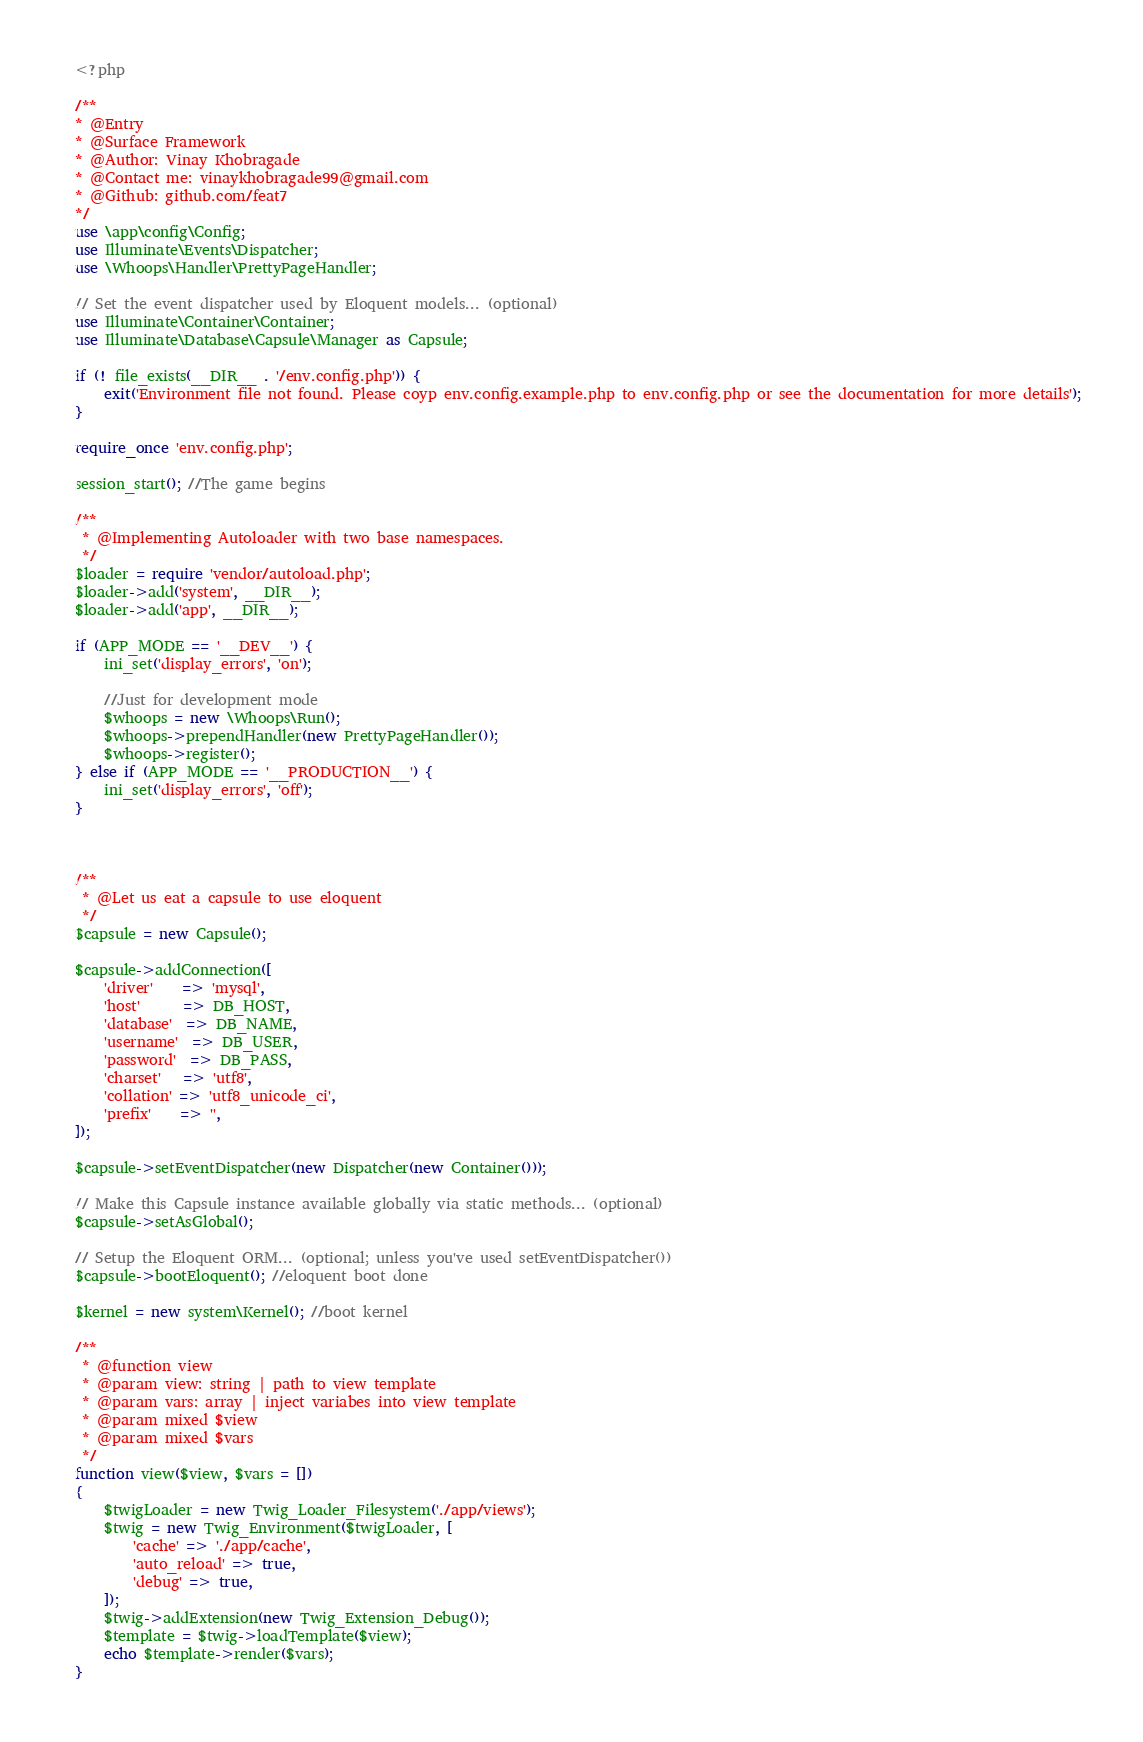Convert code to text. <code><loc_0><loc_0><loc_500><loc_500><_PHP_><?php

/**
* @Entry
* @Surface Framework
* @Author: Vinay Khobragade
* @Contact me: vinaykhobragade99@gmail.com
* @Github: github.com/feat7
*/
use \app\config\Config;
use Illuminate\Events\Dispatcher;
use \Whoops\Handler\PrettyPageHandler;

// Set the event dispatcher used by Eloquent models... (optional)
use Illuminate\Container\Container;
use Illuminate\Database\Capsule\Manager as Capsule;

if (! file_exists(__DIR__ . '/env.config.php')) {
    exit('Environment file not found. Please coyp env.config.example.php to env.config.php or see the documentation for more details');
}

require_once 'env.config.php';

session_start(); //The game begins

/**
 * @Implementing Autoloader with two base namespaces.
 */
$loader = require 'vendor/autoload.php';
$loader->add('system', __DIR__);
$loader->add('app', __DIR__);

if (APP_MODE == '__DEV__') {
    ini_set('display_errors', 'on');

    //Just for development mode
    $whoops = new \Whoops\Run();
    $whoops->prependHandler(new PrettyPageHandler());
    $whoops->register();
} else if (APP_MODE == '__PRODUCTION__') {
    ini_set('display_errors', 'off');
} 



/**
 * @Let us eat a capsule to use eloquent
 */
$capsule = new Capsule();

$capsule->addConnection([
    'driver'    => 'mysql',
    'host'      => DB_HOST,
    'database'  => DB_NAME,
    'username'  => DB_USER,
    'password'  => DB_PASS,
    'charset'   => 'utf8',
    'collation' => 'utf8_unicode_ci',
    'prefix'    => '',
]);

$capsule->setEventDispatcher(new Dispatcher(new Container()));

// Make this Capsule instance available globally via static methods... (optional)
$capsule->setAsGlobal();

// Setup the Eloquent ORM... (optional; unless you've used setEventDispatcher())
$capsule->bootEloquent(); //eloquent boot done

$kernel = new system\Kernel(); //boot kernel

/**
 * @function view
 * @param view: string | path to view template
 * @param vars: array | inject variabes into view template
 * @param mixed $view
 * @param mixed $vars
 */
function view($view, $vars = [])
{
    $twigLoader = new Twig_Loader_Filesystem('./app/views');
    $twig = new Twig_Environment($twigLoader, [
        'cache' => './app/cache',
        'auto_reload' => true,
        'debug' => true,
    ]);
    $twig->addExtension(new Twig_Extension_Debug());
    $template = $twig->loadTemplate($view);
    echo $template->render($vars);
}
</code> 